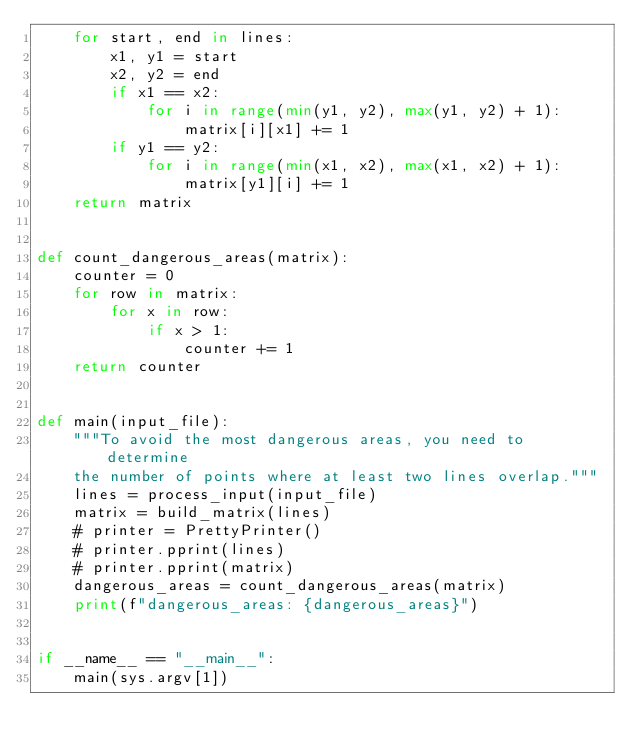<code> <loc_0><loc_0><loc_500><loc_500><_Python_>    for start, end in lines:
        x1, y1 = start
        x2, y2 = end
        if x1 == x2:
            for i in range(min(y1, y2), max(y1, y2) + 1):
                matrix[i][x1] += 1
        if y1 == y2:
            for i in range(min(x1, x2), max(x1, x2) + 1):
                matrix[y1][i] += 1
    return matrix


def count_dangerous_areas(matrix):
    counter = 0
    for row in matrix:
        for x in row:
            if x > 1:
                counter += 1
    return counter


def main(input_file):
    """To avoid the most dangerous areas, you need to determine
    the number of points where at least two lines overlap."""
    lines = process_input(input_file)
    matrix = build_matrix(lines)
    # printer = PrettyPrinter()
    # printer.pprint(lines)
    # printer.pprint(matrix)
    dangerous_areas = count_dangerous_areas(matrix)
    print(f"dangerous_areas: {dangerous_areas}")


if __name__ == "__main__":
    main(sys.argv[1])
</code> 